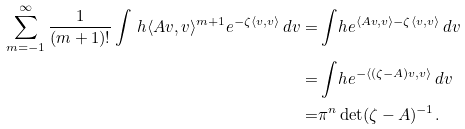<formula> <loc_0><loc_0><loc_500><loc_500>\sum _ { m = - 1 } ^ { \infty } \frac { 1 } { ( m + 1 ) ! } \int _ { \ } h \langle A v , v \rangle ^ { m + 1 } e ^ { - \zeta \langle v , v \rangle } \, d v = & \int _ { \ } h e ^ { \langle A v , v \rangle - \zeta \langle v , v \rangle } \, d v \\ = & \int _ { \ } h e ^ { - \langle ( \zeta - A ) v , v \rangle } \, d v \\ = & \pi ^ { n } \det ( \zeta - A ) ^ { - 1 } .</formula> 